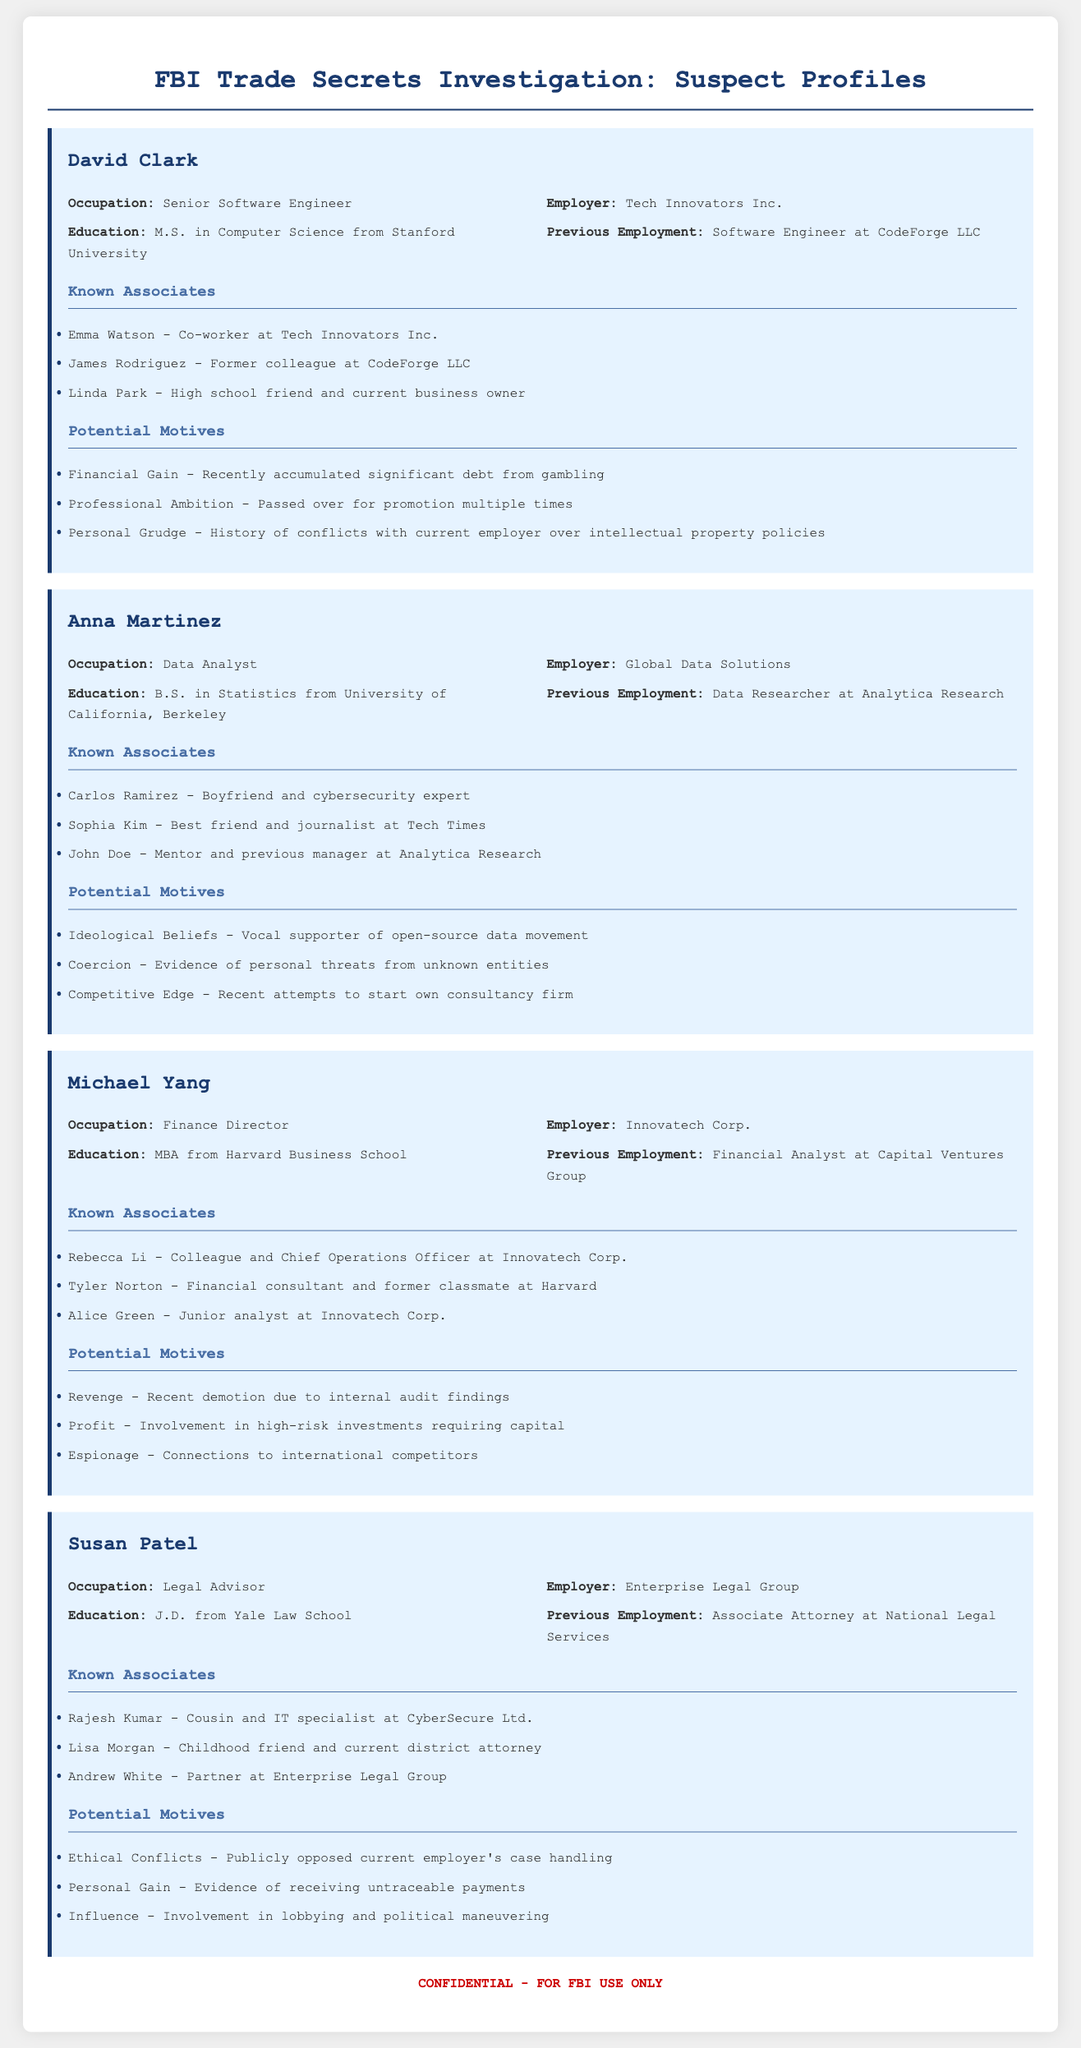What is David Clark's occupation? David Clark's occupation is listed in the document as Senior Software Engineer.
Answer: Senior Software Engineer Who is Anna Martinez's boyfriend? The document states that Anna Martinez's boyfriend is Carlos Ramirez, who is a cybersecurity expert.
Answer: Carlos Ramirez What law school did Susan Patel attend? The document mentions that Susan Patel received her J.D. from Yale Law School.
Answer: Yale Law School How many known associates does Michael Yang have? The document lists three known associates for Michael Yang.
Answer: Three What is a potential motive for David Clark? The document outlines several potential motives for David Clark, including financial gain, professional ambition, and personal grudge.
Answer: Financial Gain Which suspect has an MBA? The document indicates that Michael Yang has an MBA from Harvard Business School.
Answer: Michael Yang What is the education background of Anna Martinez? Anna Martinez has a B.S. in Statistics from the University of California, Berkeley, according to the document.
Answer: B.S. in Statistics What type of organization does Susan Patel work for? The document states that Susan Patel works for Enterprise Legal Group, which is a legal organization.
Answer: Enterprise Legal Group What previous employment did David Clark have? The document notes that David Clark's previous employment was as a Software Engineer at CodeForge LLC.
Answer: Software Engineer at CodeForge LLC 